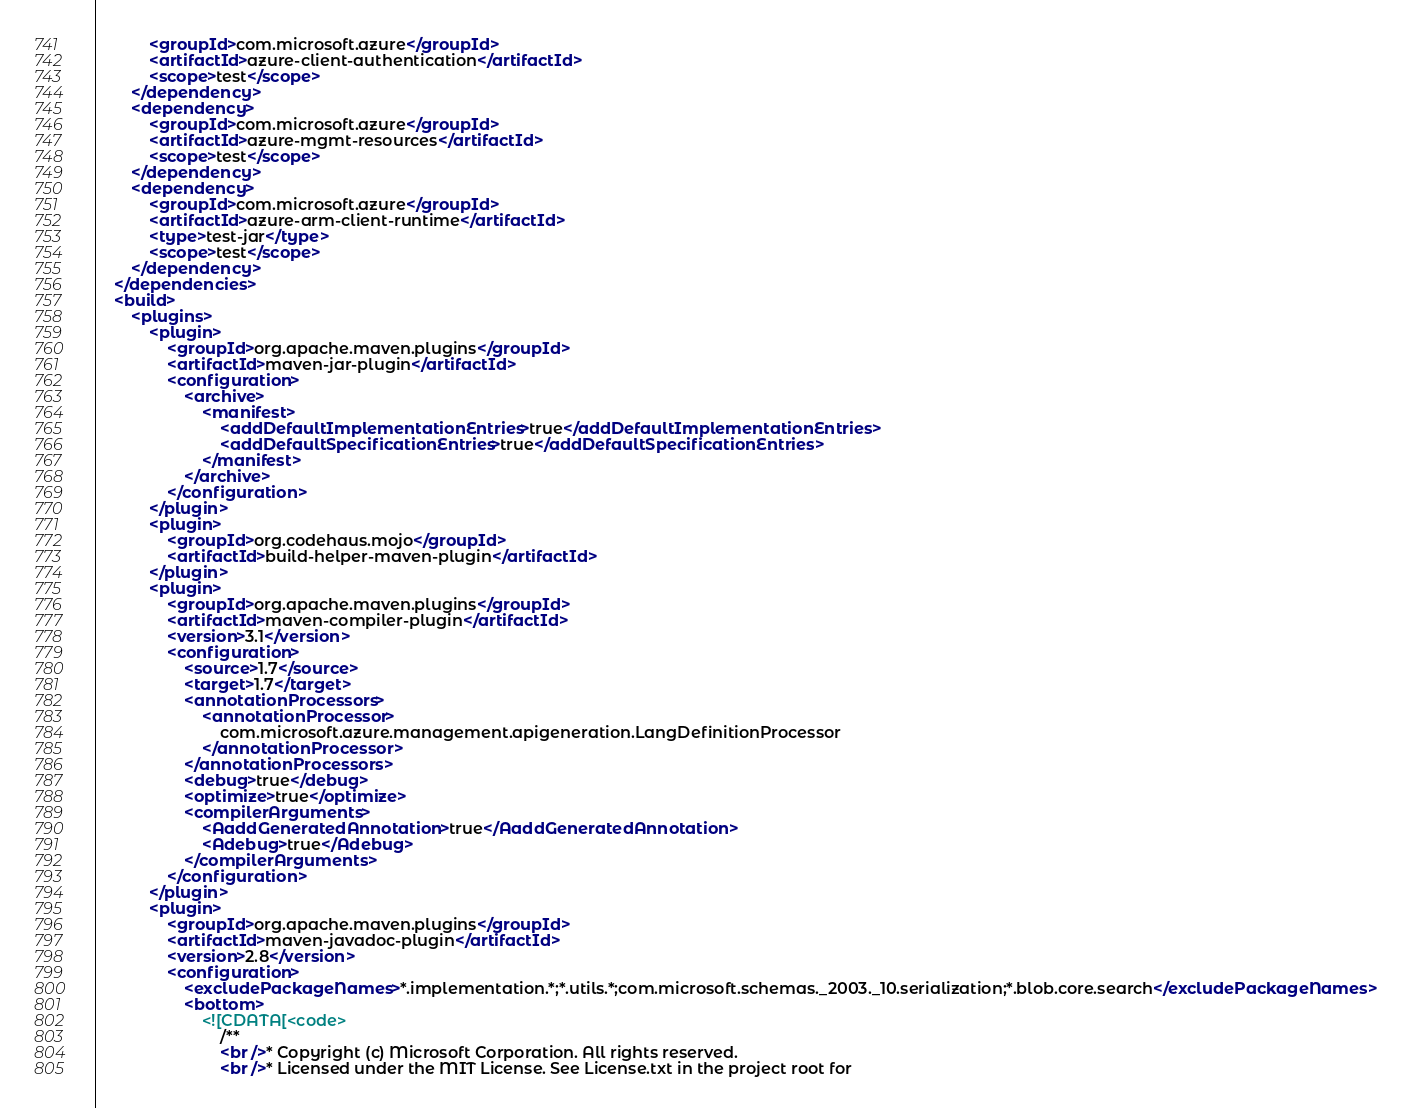Convert code to text. <code><loc_0><loc_0><loc_500><loc_500><_XML_>            <groupId>com.microsoft.azure</groupId>
            <artifactId>azure-client-authentication</artifactId>
            <scope>test</scope>
        </dependency>
        <dependency>
            <groupId>com.microsoft.azure</groupId>
            <artifactId>azure-mgmt-resources</artifactId>
            <scope>test</scope>
        </dependency>
        <dependency>
            <groupId>com.microsoft.azure</groupId>
            <artifactId>azure-arm-client-runtime</artifactId>
            <type>test-jar</type>
            <scope>test</scope>
        </dependency>
    </dependencies>
    <build>
        <plugins>
            <plugin>
                <groupId>org.apache.maven.plugins</groupId>
                <artifactId>maven-jar-plugin</artifactId>
                <configuration>
                    <archive>
                        <manifest>
                            <addDefaultImplementationEntries>true</addDefaultImplementationEntries>
                            <addDefaultSpecificationEntries>true</addDefaultSpecificationEntries>
                        </manifest>
                    </archive>
                </configuration>
            </plugin>
            <plugin>
                <groupId>org.codehaus.mojo</groupId>
                <artifactId>build-helper-maven-plugin</artifactId>
            </plugin>
            <plugin>
                <groupId>org.apache.maven.plugins</groupId>
                <artifactId>maven-compiler-plugin</artifactId>
                <version>3.1</version>
                <configuration>
                    <source>1.7</source>
                    <target>1.7</target>
                    <annotationProcessors>
                        <annotationProcessor>
                            com.microsoft.azure.management.apigeneration.LangDefinitionProcessor
                        </annotationProcessor>
                    </annotationProcessors>
                    <debug>true</debug>
                    <optimize>true</optimize>
                    <compilerArguments>
                        <AaddGeneratedAnnotation>true</AaddGeneratedAnnotation>
                        <Adebug>true</Adebug>
                    </compilerArguments>
                </configuration>
            </plugin>
            <plugin>
                <groupId>org.apache.maven.plugins</groupId>
                <artifactId>maven-javadoc-plugin</artifactId>
                <version>2.8</version>
                <configuration>
                    <excludePackageNames>*.implementation.*;*.utils.*;com.microsoft.schemas._2003._10.serialization;*.blob.core.search</excludePackageNames>
                    <bottom>
                        <![CDATA[<code>
                            /**
                            <br />* Copyright (c) Microsoft Corporation. All rights reserved.
                            <br />* Licensed under the MIT License. See License.txt in the project root for</code> 